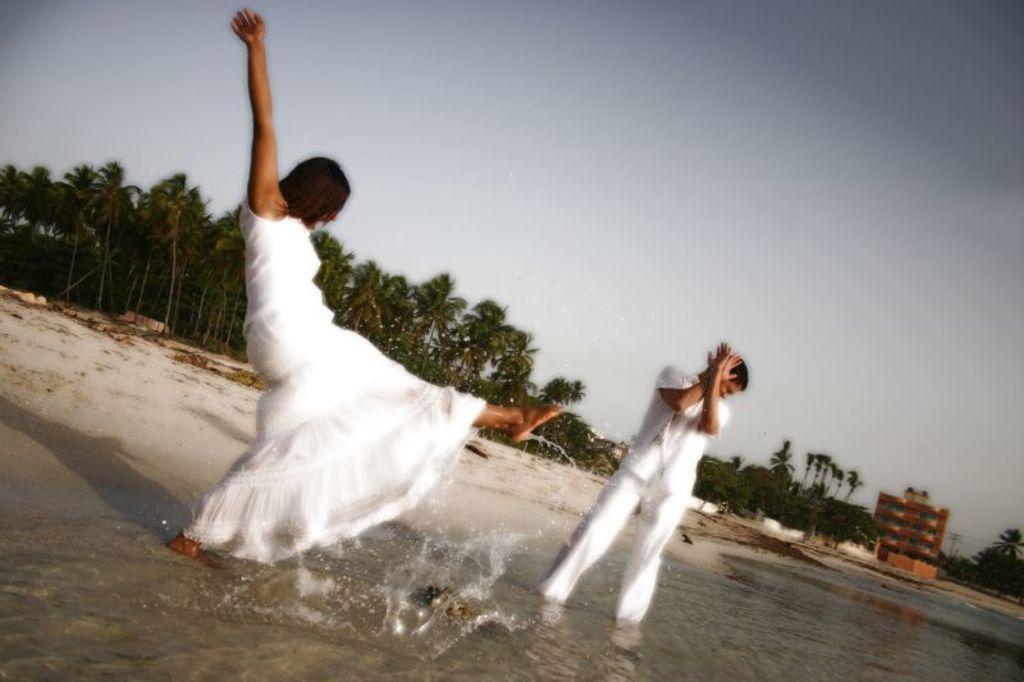Please provide a concise description of this image. In this picture we can see people standing on water and in the background we can see a building,trees,sky. 